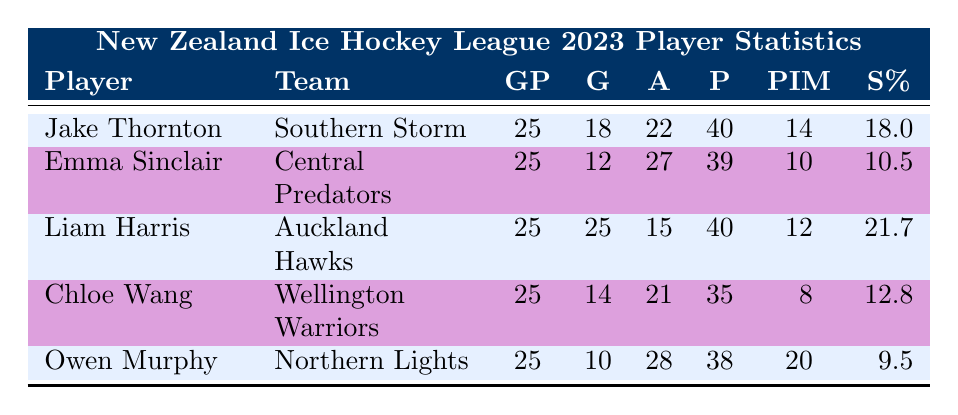What is the total number of goals scored by all players listed? To find the total number of goals, I will add the goals of each player: 18 (Jake) + 12 (Emma) + 25 (Liam) + 14 (Chloe) + 10 (Owen) = 79.
Answer: 79 Which player has the highest shooting percentage? By comparing the shooting percentages of all players, I see that Liam Harris has a shooting percentage of 21.7, which is the highest compared to the others (18.0, 10.5, 12.8, 9.5).
Answer: Liam Harris How many assists did Owen Murphy record? Owen Murphy's assists are clearly listed as 28 in the table. No calculations are needed for this retrieval question.
Answer: 28 Is it true that Chloe Wang had more points than Emma Sinclair? Chloe Wang has 35 points and Emma Sinclair has 39 points. Since 35 is less than 39, the statement is false.
Answer: No What is the average number of penalty minutes per player? There are 5 players, and I will first sum the penalty minutes: 14 (Jake) + 10 (Emma) + 12 (Liam) + 8 (Chloe) + 20 (Owen) = 74. Then, I divide by the number of players: 74/5 = 14.8.
Answer: 14.8 Which team did Jake Thornton play for, and how many points did he score? Jake Thornton is listed as playing for the Southern Storm, and his points total is shown as 40. This requires retrieving two facts from the same row.
Answer: Southern Storm, 40 If I combine the goals scored by Jake Thornton and Chloe Wang, how many goals is that? Jake Thornton scored 18 goals and Chloe Wang scored 14 goals. Adding these together gives 18 + 14 = 32 goals.
Answer: 32 What is the total number of games played by all players combined? Each player played 25 games: 5 players multiplied by 25 equals a total of 125 games played across all players.
Answer: 125 